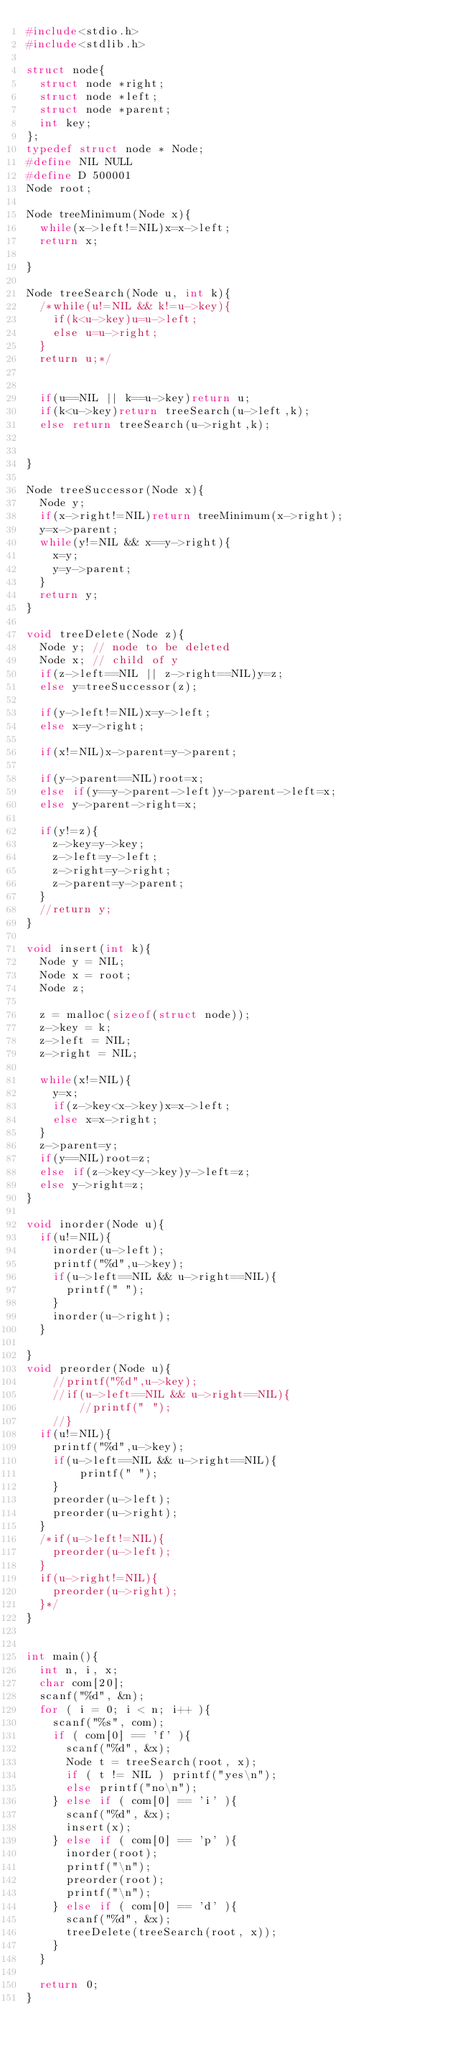Convert code to text. <code><loc_0><loc_0><loc_500><loc_500><_C_>#include<stdio.h>
#include<stdlib.h>
 
struct node{
  struct node *right;
  struct node *left;
  struct node *parent;
  int key;
};
typedef struct node * Node;
#define NIL NULL
#define D 500001 
Node root;
 
Node treeMinimum(Node x){
  while(x->left!=NIL)x=x->left;
  return x;
 
}
 
Node treeSearch(Node u, int k){
  /*while(u!=NIL && k!=u->key){
    if(k<u->key)u=u->left;
    else u=u->right;
  }
  return u;*/

 
  if(u==NIL || k==u->key)return u;
  if(k<u->key)return treeSearch(u->left,k);
  else return treeSearch(u->right,k);
  
 
}
 
Node treeSuccessor(Node x){
  Node y;
  if(x->right!=NIL)return treeMinimum(x->right);
  y=x->parent;
  while(y!=NIL && x==y->right){
    x=y;
    y=y->parent;
  }
  return y;
}
 
void treeDelete(Node z){
  Node y; // node to be deleted
  Node x; // child of y
  if(z->left==NIL || z->right==NIL)y=z;
  else y=treeSuccessor(z);
 
  if(y->left!=NIL)x=y->left;
  else x=y->right;
 
  if(x!=NIL)x->parent=y->parent;
 
  if(y->parent==NIL)root=x;
  else if(y==y->parent->left)y->parent->left=x;
  else y->parent->right=x;
 
  if(y!=z){
    z->key=y->key;
    z->left=y->left;
    z->right=y->right;
    z->parent=y->parent;
  }
  //return y;
}
 
void insert(int k){
  Node y = NIL;
  Node x = root;
  Node z;
 
  z = malloc(sizeof(struct node));
  z->key = k;
  z->left = NIL;
  z->right = NIL;
 
  while(x!=NIL){
    y=x;
    if(z->key<x->key)x=x->left;
    else x=x->right;
  }
  z->parent=y;
  if(y==NIL)root=z;
  else if(z->key<y->key)y->left=z;
  else y->right=z;
}
 
void inorder(Node u){
  if(u!=NIL){
    inorder(u->left);
    printf("%d",u->key);
    if(u->left==NIL && u->right==NIL){
      printf(" ");
    }
    inorder(u->right);
  }
 
}
void preorder(Node u){
	//printf("%d",u->key);
	//if(u->left==NIL && u->right==NIL){
		//printf(" ");
	//}
  if(u!=NIL){
	printf("%d",u->key);
	if(u->left==NIL && u->right==NIL){
		printf(" ");
	}
	preorder(u->left);
	preorder(u->right);
  }
  /*if(u->left!=NIL){
    preorder(u->left);
  }
  if(u->right!=NIL){
    preorder(u->right);
  }*/
}
 
 
int main(){
  int n, i, x;
  char com[20];
  scanf("%d", &n);
  for ( i = 0; i < n; i++ ){
    scanf("%s", com);
    if ( com[0] == 'f' ){
      scanf("%d", &x);
      Node t = treeSearch(root, x);
      if ( t != NIL ) printf("yes\n");
      else printf("no\n");
    } else if ( com[0] == 'i' ){
      scanf("%d", &x);
      insert(x);
    } else if ( com[0] == 'p' ){
      inorder(root);
      printf("\n");
      preorder(root);
      printf("\n");
    } else if ( com[0] == 'd' ){
      scanf("%d", &x);
      treeDelete(treeSearch(root, x));
    }
  }
 
  return 0;
}</code> 